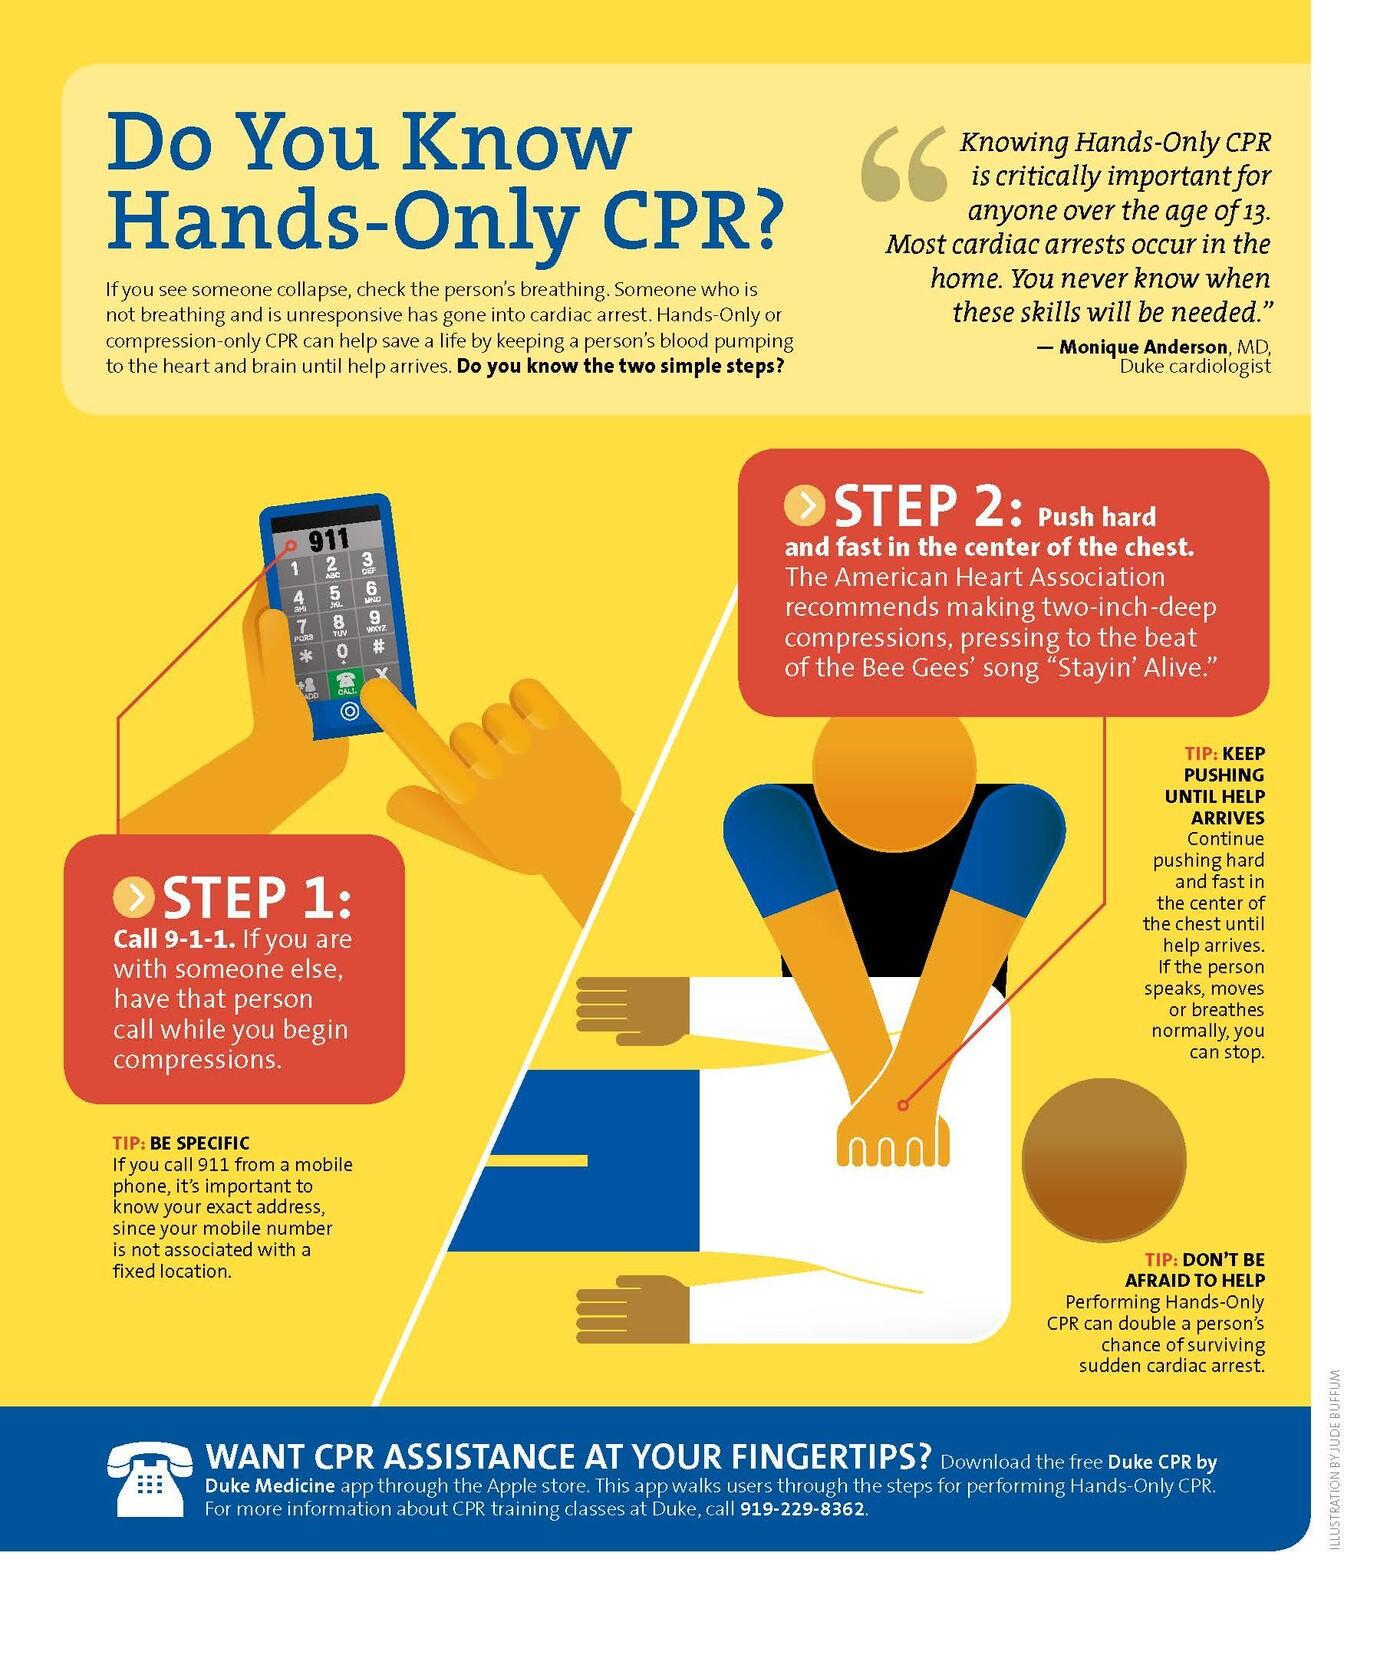Highlight a few significant elements in this photo. When witnessing a collapse, it is imperative to immediately call 9-1-1 as the first course of action. It is imperative to push hard and fast in the center of the chest immediately following a call for help. 